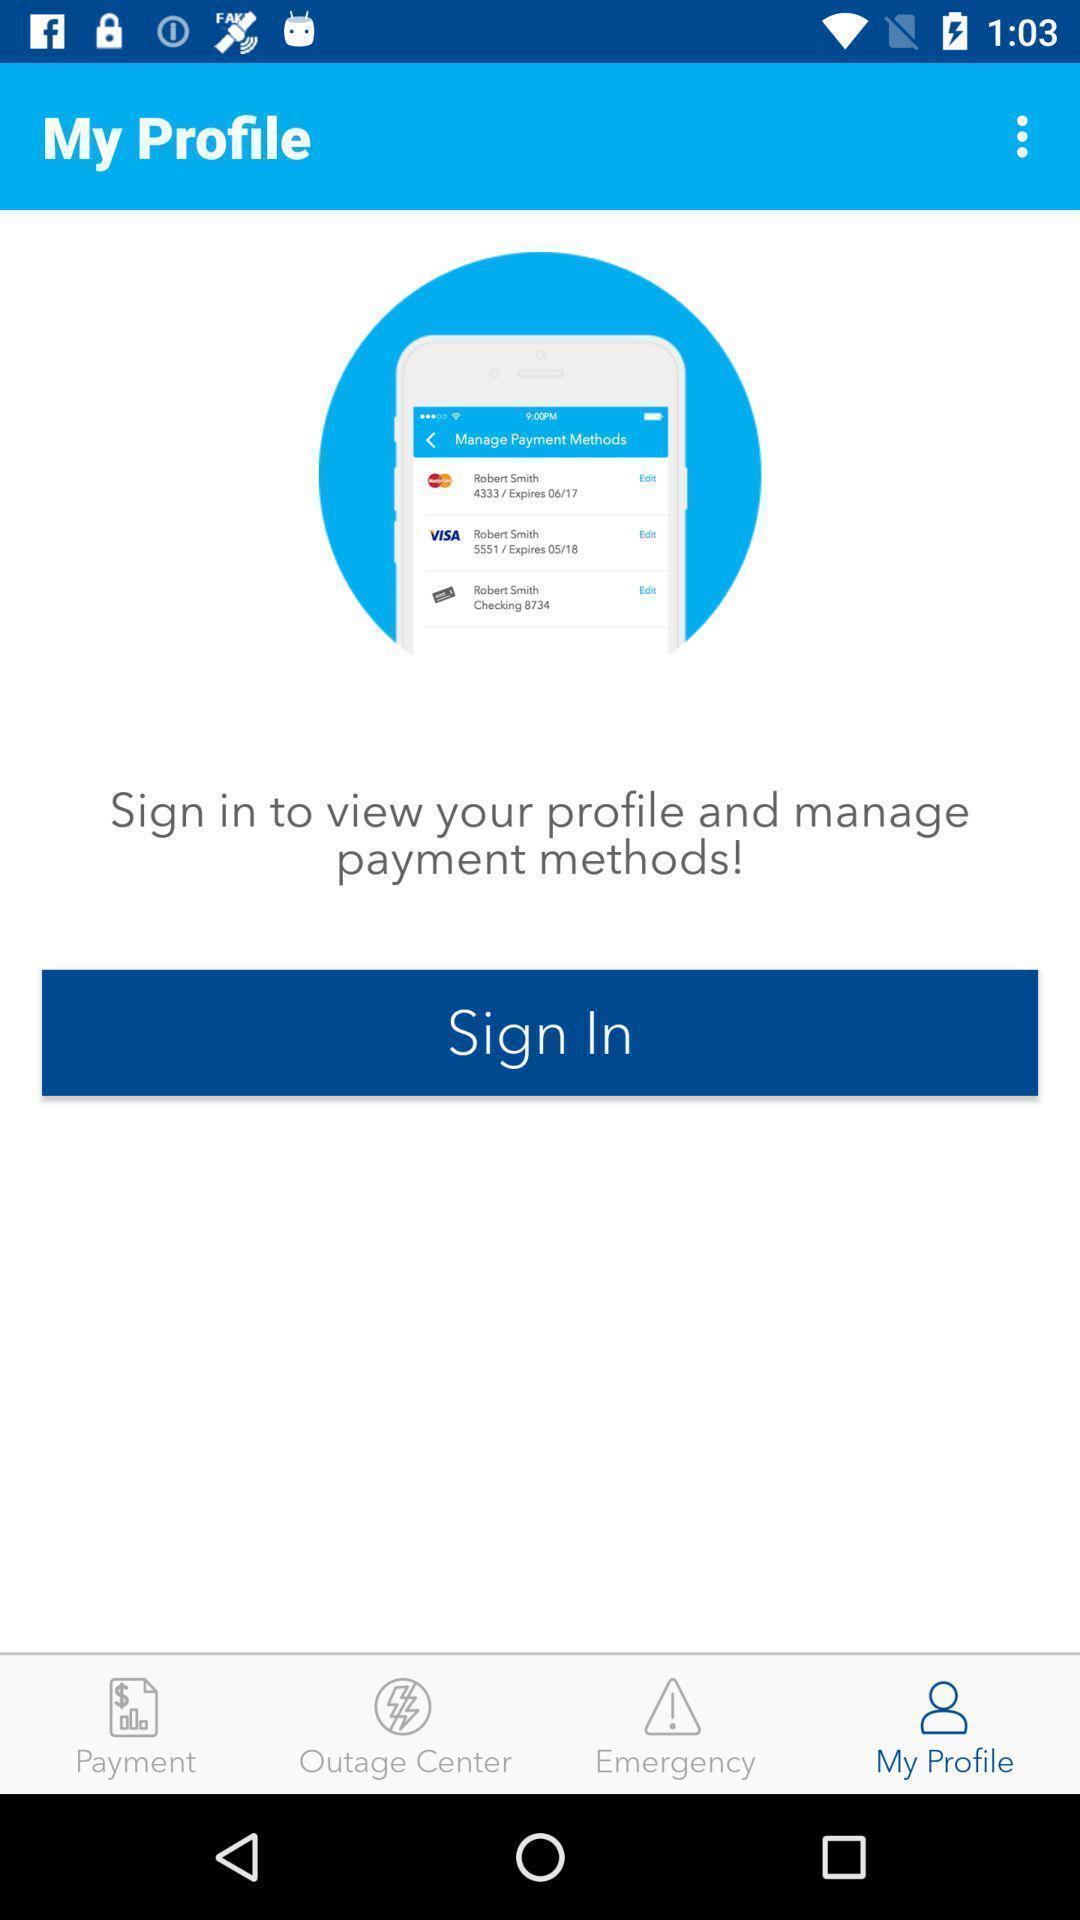Give me a summary of this screen capture. Sign-in page of a social app. 